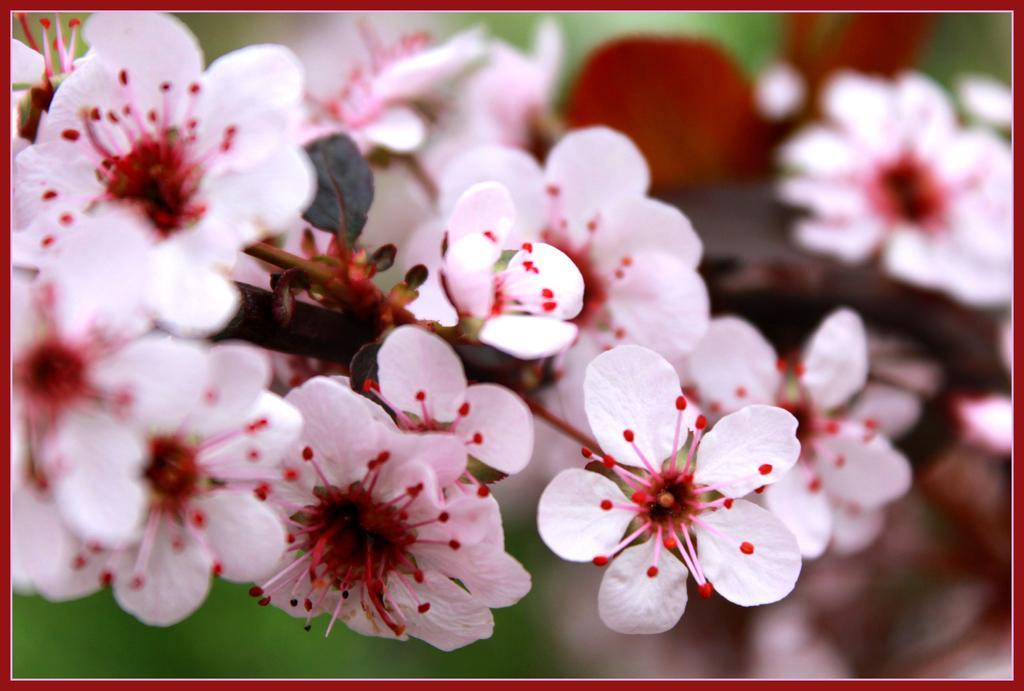In one or two sentences, can you explain what this image depicts? In the image we can see some flowers. 